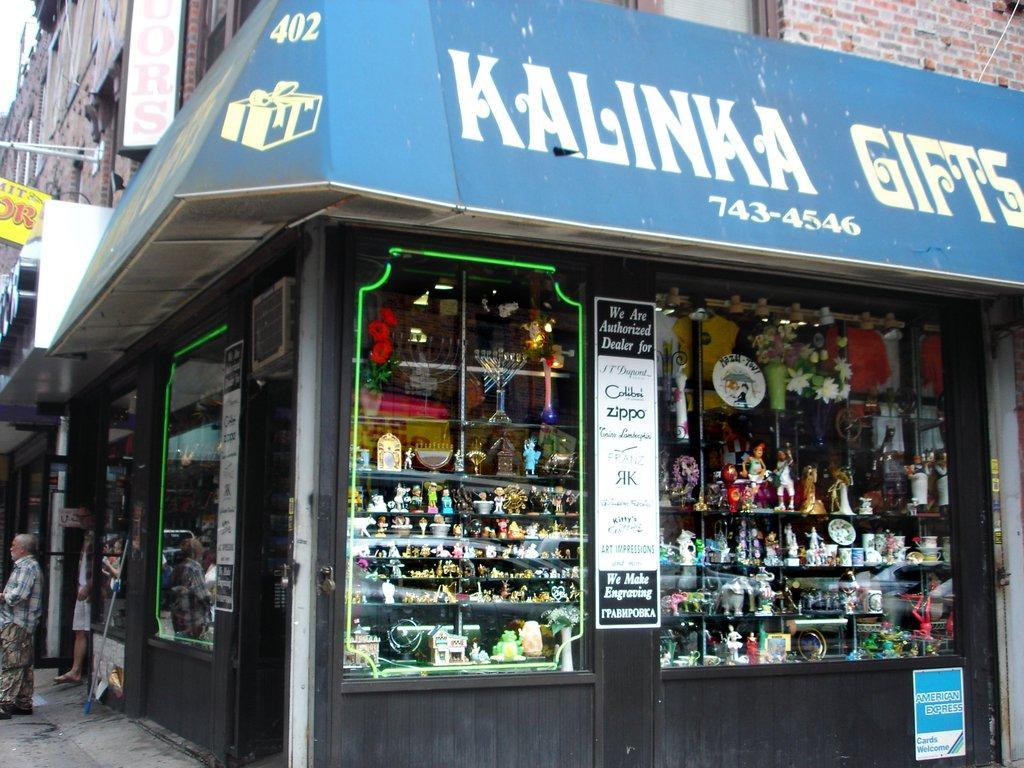How would you summarize this image in a sentence or two? In this image we can see buildings, there is a shop, there are some objects on the racks, there are windows, pole, boards, and poster with some text written on it, there are two persons. 